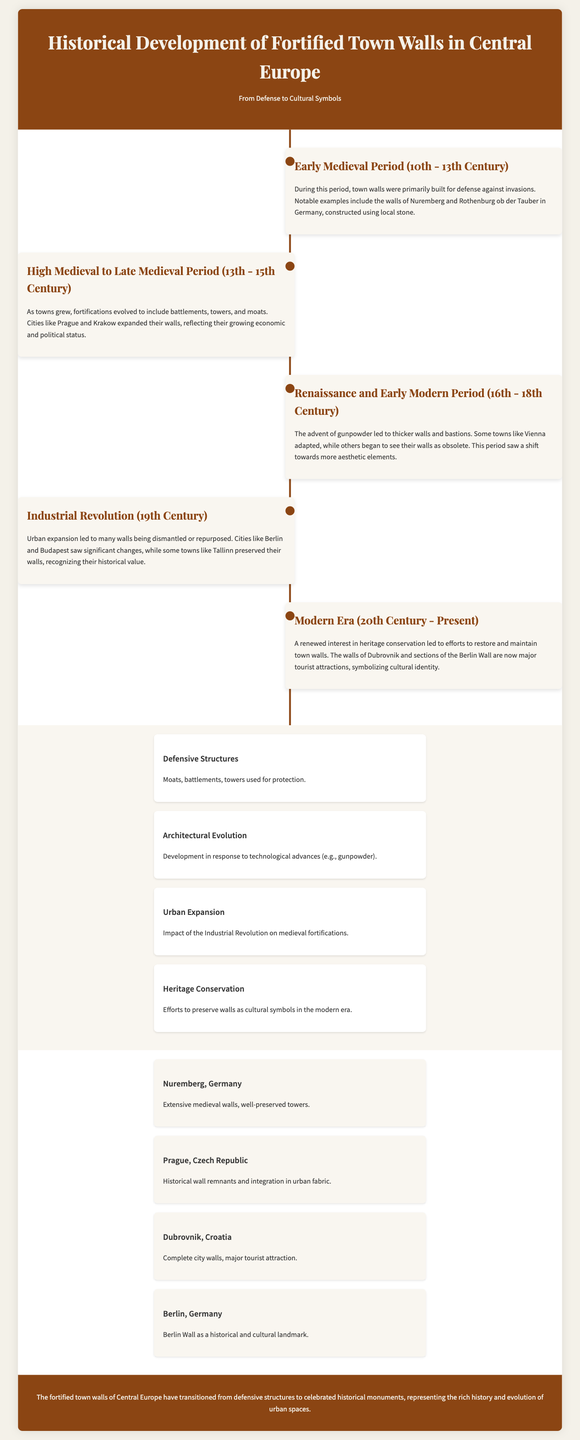what were fortified town walls primarily built for in the early medieval period? According to the document, they were built primarily for defense against invasions.
Answer: defense against invasions which cities expanded their walls during the high to late medieval period? The document mentions that cities like Prague and Krakow expanded their walls during this period.
Answer: Prague and Krakow what technological advancement influenced the architectural evolution of town walls in the 16th to 18th century? The document states that the advent of gunpowder influenced the architectural evolution of town walls during this period.
Answer: gunpowder in which century did urban expansion lead to many walls being dismantled or repurposed? The document indicates that the 19th century saw urban expansion leading to walls being dismantled or repurposed.
Answer: 19th century which city is noted for having complete city walls and being a major tourist attraction? The document highlights Dubrovnik for having complete city walls and being a major tourist attraction.
Answer: Dubrovnik what feature is emphasized as part of the defensive structures in the document? The document lists moats as part of the defensive structures.
Answer: moats how have the fortified town walls transitioned according to the document? The document explains that they have transitioned from defensive structures to celebrated historical monuments.
Answer: celebrated historical monuments what is a key aspect of modern efforts regarding town walls? The document states that a key aspect is heritage conservation in the modern era.
Answer: heritage conservation name one case study that mentions a historical and cultural landmark. The document mentions the Berlin Wall as a historical and cultural landmark in its case studies section.
Answer: Berlin Wall 